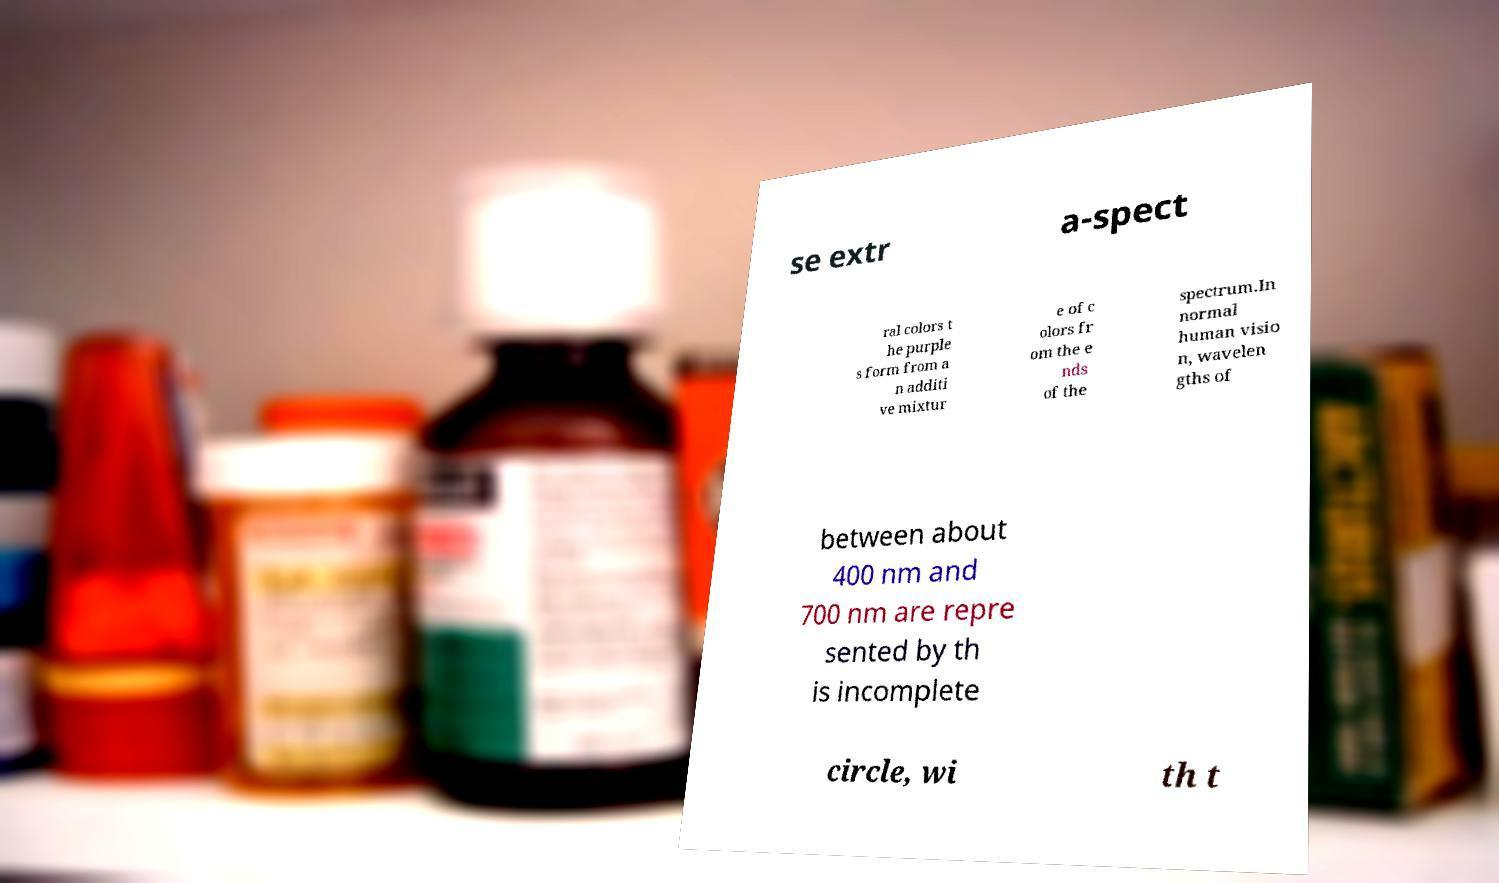Please identify and transcribe the text found in this image. se extr a-spect ral colors t he purple s form from a n additi ve mixtur e of c olors fr om the e nds of the spectrum.In normal human visio n, wavelen gths of between about 400 nm and 700 nm are repre sented by th is incomplete circle, wi th t 